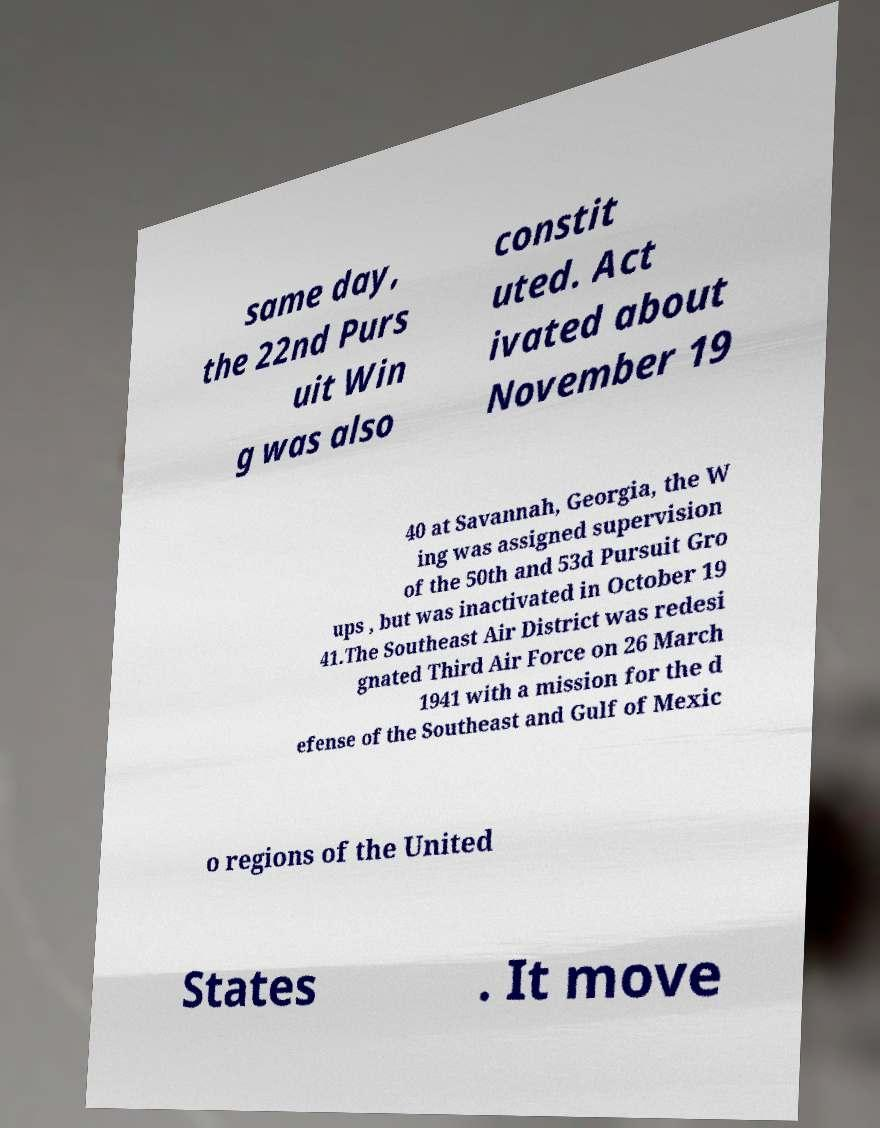Please read and relay the text visible in this image. What does it say? same day, the 22nd Purs uit Win g was also constit uted. Act ivated about November 19 40 at Savannah, Georgia, the W ing was assigned supervision of the 50th and 53d Pursuit Gro ups , but was inactivated in October 19 41.The Southeast Air District was redesi gnated Third Air Force on 26 March 1941 with a mission for the d efense of the Southeast and Gulf of Mexic o regions of the United States . It move 